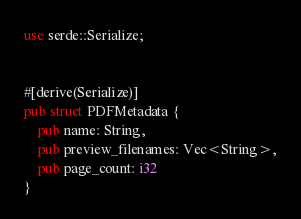<code> <loc_0><loc_0><loc_500><loc_500><_Rust_>use serde::Serialize;


#[derive(Serialize)]
pub struct PDFMetadata {
    pub name: String,
    pub preview_filenames: Vec<String>,
    pub page_count: i32
}

</code> 